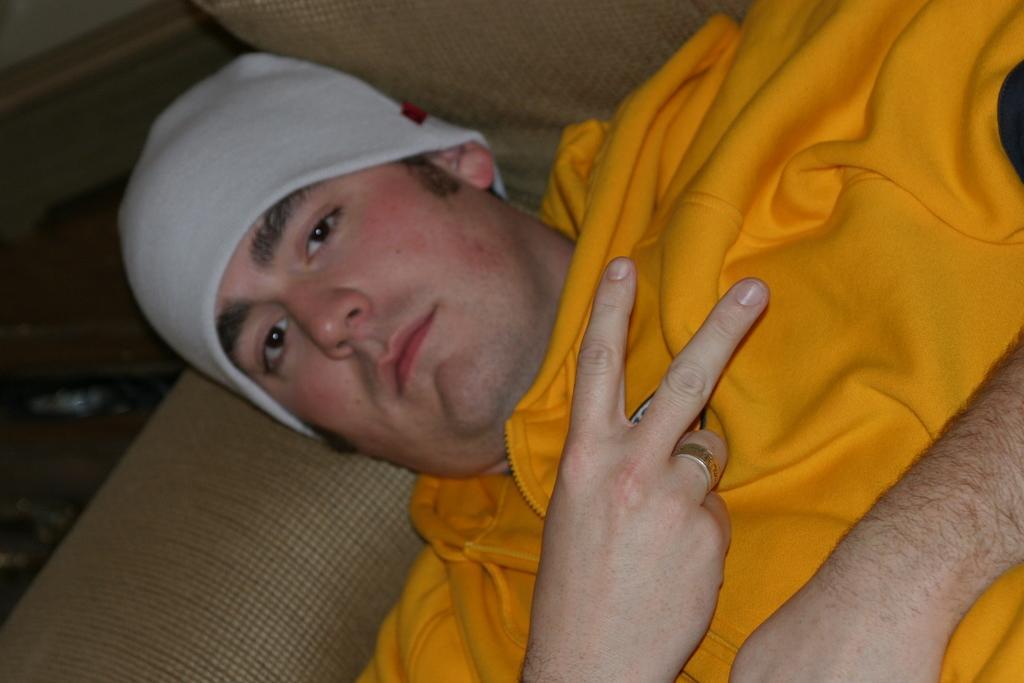Describe this image in one or two sentences. In this image a person is on the sofa. He is wearing a yellow jacket and a cap. Beside there is a bag on the floor. 